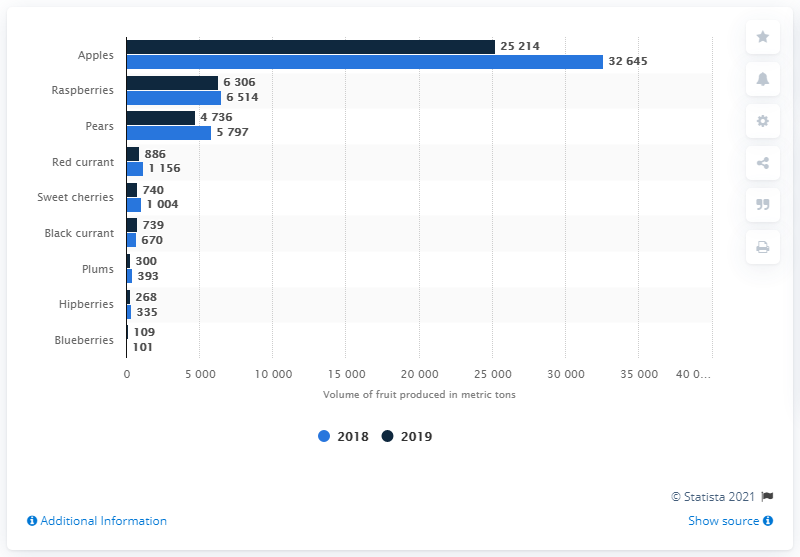Identify some key points in this picture. In 2019, a total of 25,214 metric tons of apples were produced in Denmark. 